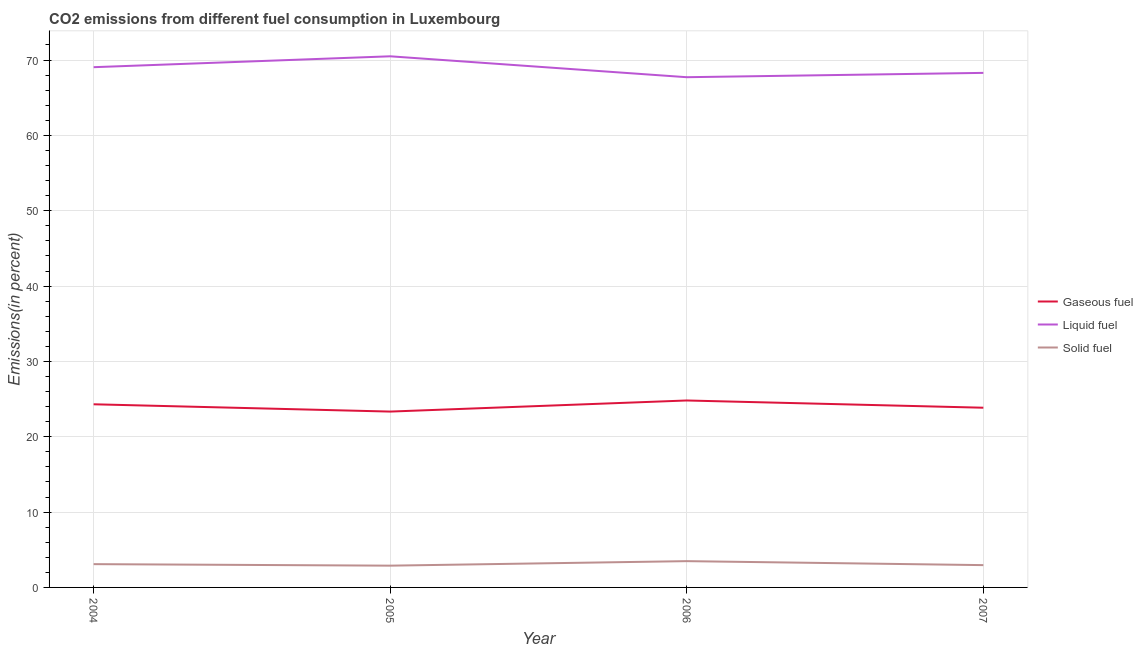What is the percentage of gaseous fuel emission in 2005?
Give a very brief answer. 23.34. Across all years, what is the maximum percentage of gaseous fuel emission?
Provide a succinct answer. 24.81. Across all years, what is the minimum percentage of solid fuel emission?
Ensure brevity in your answer.  2.89. In which year was the percentage of liquid fuel emission maximum?
Your response must be concise. 2005. In which year was the percentage of gaseous fuel emission minimum?
Keep it short and to the point. 2005. What is the total percentage of liquid fuel emission in the graph?
Provide a succinct answer. 275.57. What is the difference between the percentage of gaseous fuel emission in 2005 and that in 2006?
Your answer should be very brief. -1.47. What is the difference between the percentage of gaseous fuel emission in 2006 and the percentage of liquid fuel emission in 2004?
Keep it short and to the point. -44.24. What is the average percentage of liquid fuel emission per year?
Make the answer very short. 68.89. In the year 2007, what is the difference between the percentage of gaseous fuel emission and percentage of liquid fuel emission?
Ensure brevity in your answer.  -44.44. What is the ratio of the percentage of solid fuel emission in 2004 to that in 2006?
Provide a short and direct response. 0.89. Is the percentage of solid fuel emission in 2004 less than that in 2006?
Make the answer very short. Yes. Is the difference between the percentage of solid fuel emission in 2004 and 2006 greater than the difference between the percentage of gaseous fuel emission in 2004 and 2006?
Provide a succinct answer. Yes. What is the difference between the highest and the second highest percentage of gaseous fuel emission?
Your answer should be compact. 0.51. What is the difference between the highest and the lowest percentage of gaseous fuel emission?
Offer a terse response. 1.47. Is the sum of the percentage of liquid fuel emission in 2005 and 2006 greater than the maximum percentage of solid fuel emission across all years?
Give a very brief answer. Yes. Does the percentage of gaseous fuel emission monotonically increase over the years?
Ensure brevity in your answer.  No. Is the percentage of gaseous fuel emission strictly less than the percentage of liquid fuel emission over the years?
Your answer should be compact. Yes. How many lines are there?
Your response must be concise. 3. What is the difference between two consecutive major ticks on the Y-axis?
Ensure brevity in your answer.  10. Does the graph contain grids?
Offer a very short reply. Yes. How many legend labels are there?
Your answer should be very brief. 3. What is the title of the graph?
Provide a succinct answer. CO2 emissions from different fuel consumption in Luxembourg. What is the label or title of the Y-axis?
Make the answer very short. Emissions(in percent). What is the Emissions(in percent) of Gaseous fuel in 2004?
Give a very brief answer. 24.31. What is the Emissions(in percent) of Liquid fuel in 2004?
Give a very brief answer. 69.05. What is the Emissions(in percent) of Solid fuel in 2004?
Ensure brevity in your answer.  3.09. What is the Emissions(in percent) of Gaseous fuel in 2005?
Your answer should be very brief. 23.34. What is the Emissions(in percent) of Liquid fuel in 2005?
Keep it short and to the point. 70.5. What is the Emissions(in percent) in Solid fuel in 2005?
Provide a short and direct response. 2.89. What is the Emissions(in percent) of Gaseous fuel in 2006?
Your answer should be very brief. 24.81. What is the Emissions(in percent) in Liquid fuel in 2006?
Your response must be concise. 67.72. What is the Emissions(in percent) in Solid fuel in 2006?
Ensure brevity in your answer.  3.49. What is the Emissions(in percent) of Gaseous fuel in 2007?
Provide a short and direct response. 23.85. What is the Emissions(in percent) of Liquid fuel in 2007?
Your answer should be very brief. 68.3. What is the Emissions(in percent) of Solid fuel in 2007?
Ensure brevity in your answer.  2.96. Across all years, what is the maximum Emissions(in percent) in Gaseous fuel?
Your answer should be very brief. 24.81. Across all years, what is the maximum Emissions(in percent) in Liquid fuel?
Offer a very short reply. 70.5. Across all years, what is the maximum Emissions(in percent) of Solid fuel?
Make the answer very short. 3.49. Across all years, what is the minimum Emissions(in percent) in Gaseous fuel?
Ensure brevity in your answer.  23.34. Across all years, what is the minimum Emissions(in percent) in Liquid fuel?
Give a very brief answer. 67.72. Across all years, what is the minimum Emissions(in percent) in Solid fuel?
Provide a short and direct response. 2.89. What is the total Emissions(in percent) of Gaseous fuel in the graph?
Your answer should be very brief. 96.32. What is the total Emissions(in percent) of Liquid fuel in the graph?
Keep it short and to the point. 275.57. What is the total Emissions(in percent) of Solid fuel in the graph?
Give a very brief answer. 12.43. What is the difference between the Emissions(in percent) of Gaseous fuel in 2004 and that in 2005?
Ensure brevity in your answer.  0.97. What is the difference between the Emissions(in percent) of Liquid fuel in 2004 and that in 2005?
Give a very brief answer. -1.45. What is the difference between the Emissions(in percent) of Solid fuel in 2004 and that in 2005?
Your answer should be compact. 0.2. What is the difference between the Emissions(in percent) of Gaseous fuel in 2004 and that in 2006?
Offer a very short reply. -0.51. What is the difference between the Emissions(in percent) in Liquid fuel in 2004 and that in 2006?
Provide a short and direct response. 1.33. What is the difference between the Emissions(in percent) in Solid fuel in 2004 and that in 2006?
Offer a very short reply. -0.4. What is the difference between the Emissions(in percent) in Gaseous fuel in 2004 and that in 2007?
Provide a short and direct response. 0.46. What is the difference between the Emissions(in percent) of Liquid fuel in 2004 and that in 2007?
Provide a succinct answer. 0.76. What is the difference between the Emissions(in percent) of Solid fuel in 2004 and that in 2007?
Give a very brief answer. 0.13. What is the difference between the Emissions(in percent) in Gaseous fuel in 2005 and that in 2006?
Your answer should be compact. -1.47. What is the difference between the Emissions(in percent) of Liquid fuel in 2005 and that in 2006?
Offer a terse response. 2.78. What is the difference between the Emissions(in percent) of Solid fuel in 2005 and that in 2006?
Your response must be concise. -0.6. What is the difference between the Emissions(in percent) in Gaseous fuel in 2005 and that in 2007?
Keep it short and to the point. -0.51. What is the difference between the Emissions(in percent) of Liquid fuel in 2005 and that in 2007?
Provide a succinct answer. 2.2. What is the difference between the Emissions(in percent) in Solid fuel in 2005 and that in 2007?
Offer a terse response. -0.07. What is the difference between the Emissions(in percent) of Gaseous fuel in 2006 and that in 2007?
Provide a short and direct response. 0.96. What is the difference between the Emissions(in percent) of Liquid fuel in 2006 and that in 2007?
Ensure brevity in your answer.  -0.57. What is the difference between the Emissions(in percent) of Solid fuel in 2006 and that in 2007?
Your answer should be compact. 0.53. What is the difference between the Emissions(in percent) in Gaseous fuel in 2004 and the Emissions(in percent) in Liquid fuel in 2005?
Your answer should be very brief. -46.19. What is the difference between the Emissions(in percent) in Gaseous fuel in 2004 and the Emissions(in percent) in Solid fuel in 2005?
Ensure brevity in your answer.  21.42. What is the difference between the Emissions(in percent) in Liquid fuel in 2004 and the Emissions(in percent) in Solid fuel in 2005?
Your answer should be very brief. 66.16. What is the difference between the Emissions(in percent) in Gaseous fuel in 2004 and the Emissions(in percent) in Liquid fuel in 2006?
Make the answer very short. -43.41. What is the difference between the Emissions(in percent) in Gaseous fuel in 2004 and the Emissions(in percent) in Solid fuel in 2006?
Your answer should be compact. 20.82. What is the difference between the Emissions(in percent) of Liquid fuel in 2004 and the Emissions(in percent) of Solid fuel in 2006?
Ensure brevity in your answer.  65.56. What is the difference between the Emissions(in percent) of Gaseous fuel in 2004 and the Emissions(in percent) of Liquid fuel in 2007?
Your response must be concise. -43.99. What is the difference between the Emissions(in percent) in Gaseous fuel in 2004 and the Emissions(in percent) in Solid fuel in 2007?
Offer a very short reply. 21.35. What is the difference between the Emissions(in percent) in Liquid fuel in 2004 and the Emissions(in percent) in Solid fuel in 2007?
Your response must be concise. 66.09. What is the difference between the Emissions(in percent) in Gaseous fuel in 2005 and the Emissions(in percent) in Liquid fuel in 2006?
Offer a very short reply. -44.38. What is the difference between the Emissions(in percent) in Gaseous fuel in 2005 and the Emissions(in percent) in Solid fuel in 2006?
Provide a short and direct response. 19.85. What is the difference between the Emissions(in percent) in Liquid fuel in 2005 and the Emissions(in percent) in Solid fuel in 2006?
Offer a very short reply. 67.01. What is the difference between the Emissions(in percent) in Gaseous fuel in 2005 and the Emissions(in percent) in Liquid fuel in 2007?
Offer a terse response. -44.96. What is the difference between the Emissions(in percent) of Gaseous fuel in 2005 and the Emissions(in percent) of Solid fuel in 2007?
Offer a terse response. 20.38. What is the difference between the Emissions(in percent) of Liquid fuel in 2005 and the Emissions(in percent) of Solid fuel in 2007?
Provide a succinct answer. 67.54. What is the difference between the Emissions(in percent) of Gaseous fuel in 2006 and the Emissions(in percent) of Liquid fuel in 2007?
Your answer should be very brief. -43.48. What is the difference between the Emissions(in percent) of Gaseous fuel in 2006 and the Emissions(in percent) of Solid fuel in 2007?
Make the answer very short. 21.85. What is the difference between the Emissions(in percent) of Liquid fuel in 2006 and the Emissions(in percent) of Solid fuel in 2007?
Provide a short and direct response. 64.76. What is the average Emissions(in percent) in Gaseous fuel per year?
Provide a succinct answer. 24.08. What is the average Emissions(in percent) in Liquid fuel per year?
Make the answer very short. 68.89. What is the average Emissions(in percent) of Solid fuel per year?
Provide a succinct answer. 3.11. In the year 2004, what is the difference between the Emissions(in percent) of Gaseous fuel and Emissions(in percent) of Liquid fuel?
Your answer should be very brief. -44.74. In the year 2004, what is the difference between the Emissions(in percent) of Gaseous fuel and Emissions(in percent) of Solid fuel?
Your answer should be compact. 21.22. In the year 2004, what is the difference between the Emissions(in percent) in Liquid fuel and Emissions(in percent) in Solid fuel?
Provide a succinct answer. 65.96. In the year 2005, what is the difference between the Emissions(in percent) of Gaseous fuel and Emissions(in percent) of Liquid fuel?
Offer a terse response. -47.16. In the year 2005, what is the difference between the Emissions(in percent) of Gaseous fuel and Emissions(in percent) of Solid fuel?
Provide a succinct answer. 20.45. In the year 2005, what is the difference between the Emissions(in percent) in Liquid fuel and Emissions(in percent) in Solid fuel?
Give a very brief answer. 67.61. In the year 2006, what is the difference between the Emissions(in percent) of Gaseous fuel and Emissions(in percent) of Liquid fuel?
Offer a terse response. -42.91. In the year 2006, what is the difference between the Emissions(in percent) of Gaseous fuel and Emissions(in percent) of Solid fuel?
Offer a terse response. 21.32. In the year 2006, what is the difference between the Emissions(in percent) in Liquid fuel and Emissions(in percent) in Solid fuel?
Your answer should be very brief. 64.23. In the year 2007, what is the difference between the Emissions(in percent) of Gaseous fuel and Emissions(in percent) of Liquid fuel?
Ensure brevity in your answer.  -44.44. In the year 2007, what is the difference between the Emissions(in percent) of Gaseous fuel and Emissions(in percent) of Solid fuel?
Ensure brevity in your answer.  20.89. In the year 2007, what is the difference between the Emissions(in percent) of Liquid fuel and Emissions(in percent) of Solid fuel?
Give a very brief answer. 65.34. What is the ratio of the Emissions(in percent) in Gaseous fuel in 2004 to that in 2005?
Make the answer very short. 1.04. What is the ratio of the Emissions(in percent) in Liquid fuel in 2004 to that in 2005?
Provide a succinct answer. 0.98. What is the ratio of the Emissions(in percent) in Solid fuel in 2004 to that in 2005?
Your answer should be compact. 1.07. What is the ratio of the Emissions(in percent) in Gaseous fuel in 2004 to that in 2006?
Offer a very short reply. 0.98. What is the ratio of the Emissions(in percent) of Liquid fuel in 2004 to that in 2006?
Provide a short and direct response. 1.02. What is the ratio of the Emissions(in percent) of Solid fuel in 2004 to that in 2006?
Your response must be concise. 0.89. What is the ratio of the Emissions(in percent) of Gaseous fuel in 2004 to that in 2007?
Make the answer very short. 1.02. What is the ratio of the Emissions(in percent) of Liquid fuel in 2004 to that in 2007?
Offer a very short reply. 1.01. What is the ratio of the Emissions(in percent) of Solid fuel in 2004 to that in 2007?
Ensure brevity in your answer.  1.04. What is the ratio of the Emissions(in percent) in Gaseous fuel in 2005 to that in 2006?
Offer a very short reply. 0.94. What is the ratio of the Emissions(in percent) in Liquid fuel in 2005 to that in 2006?
Offer a very short reply. 1.04. What is the ratio of the Emissions(in percent) of Solid fuel in 2005 to that in 2006?
Keep it short and to the point. 0.83. What is the ratio of the Emissions(in percent) of Gaseous fuel in 2005 to that in 2007?
Your response must be concise. 0.98. What is the ratio of the Emissions(in percent) in Liquid fuel in 2005 to that in 2007?
Offer a terse response. 1.03. What is the ratio of the Emissions(in percent) of Gaseous fuel in 2006 to that in 2007?
Your answer should be very brief. 1.04. What is the ratio of the Emissions(in percent) in Liquid fuel in 2006 to that in 2007?
Your response must be concise. 0.99. What is the ratio of the Emissions(in percent) in Solid fuel in 2006 to that in 2007?
Provide a succinct answer. 1.18. What is the difference between the highest and the second highest Emissions(in percent) in Gaseous fuel?
Your answer should be very brief. 0.51. What is the difference between the highest and the second highest Emissions(in percent) of Liquid fuel?
Give a very brief answer. 1.45. What is the difference between the highest and the second highest Emissions(in percent) in Solid fuel?
Offer a terse response. 0.4. What is the difference between the highest and the lowest Emissions(in percent) in Gaseous fuel?
Provide a short and direct response. 1.47. What is the difference between the highest and the lowest Emissions(in percent) of Liquid fuel?
Offer a terse response. 2.78. What is the difference between the highest and the lowest Emissions(in percent) of Solid fuel?
Keep it short and to the point. 0.6. 